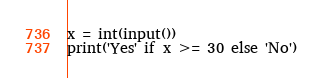Convert code to text. <code><loc_0><loc_0><loc_500><loc_500><_Python_>x = int(input())
print('Yes' if x >= 30 else 'No')</code> 